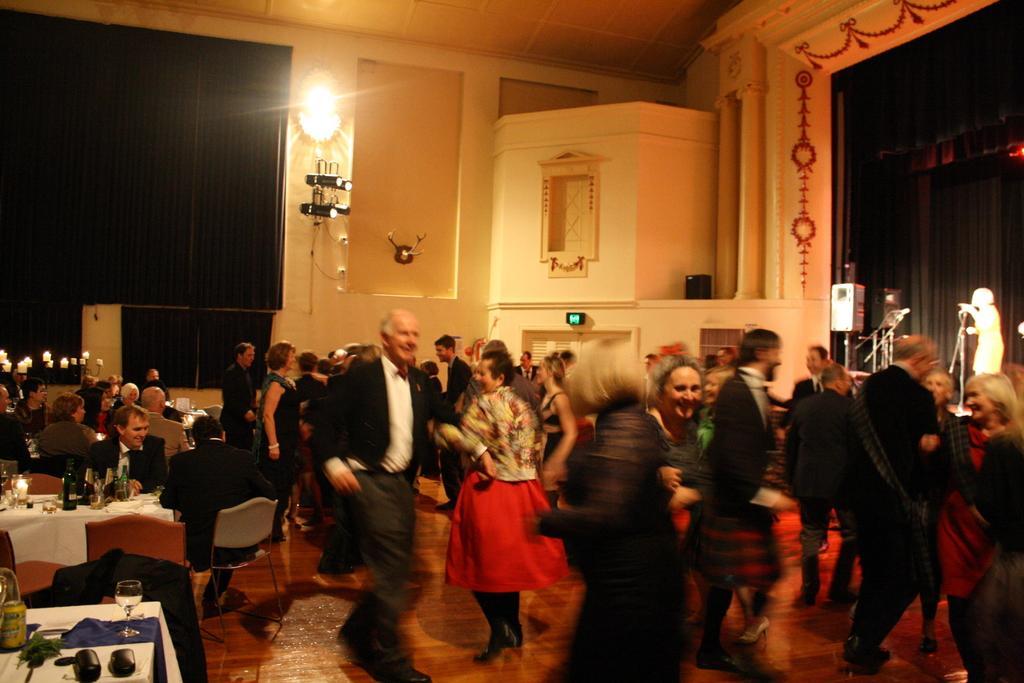In one or two sentences, can you explain what this image depicts? In this image there are group of people dancing, there are group of people sitting on the chairs, there are bottles, glasses and some other objects on the tables, and there are candles with the candles stands , there are lights , mike's with the miles stands, a person standing on the stage. 